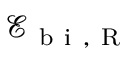Convert formula to latex. <formula><loc_0><loc_0><loc_500><loc_500>\mathcal { E } _ { b i , R }</formula> 